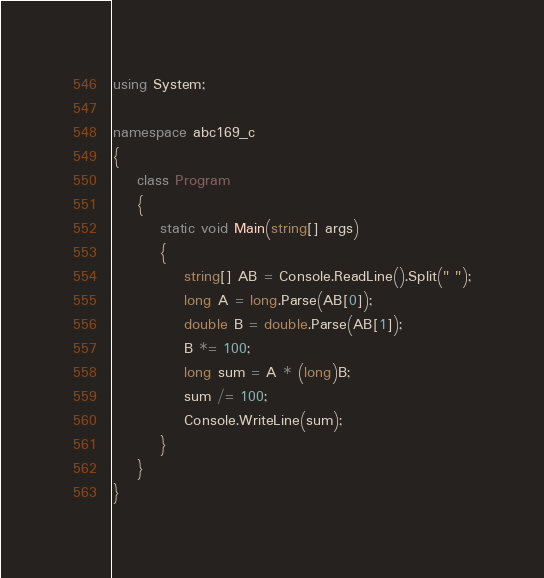Convert code to text. <code><loc_0><loc_0><loc_500><loc_500><_C#_>using System;

namespace abc169_c
{
    class Program
    {
        static void Main(string[] args)
        {
            string[] AB = Console.ReadLine().Split(" ");
            long A = long.Parse(AB[0]);
            double B = double.Parse(AB[1]);
            B *= 100;
            long sum = A * (long)B;
            sum /= 100;
            Console.WriteLine(sum);
        }
    }
}
</code> 